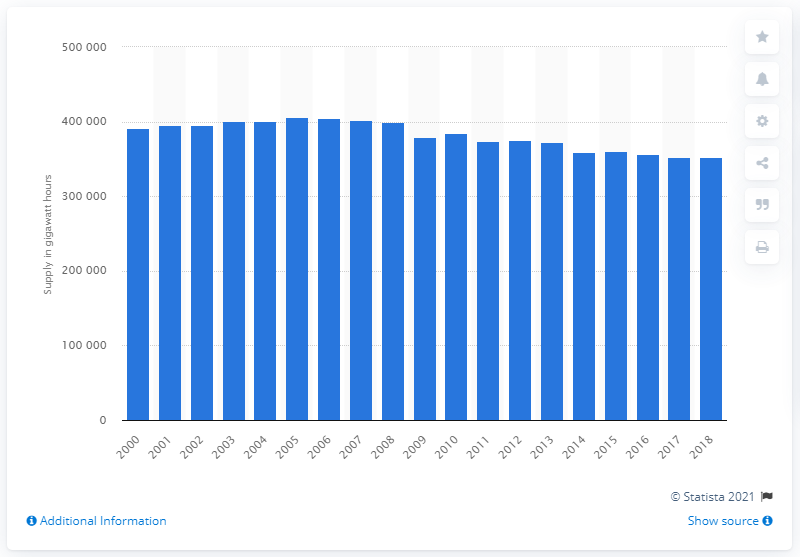Highlight a few significant elements in this photo. In 2018, the United Kingdom had approximately 352,000 gigawatt hours of electricity. 